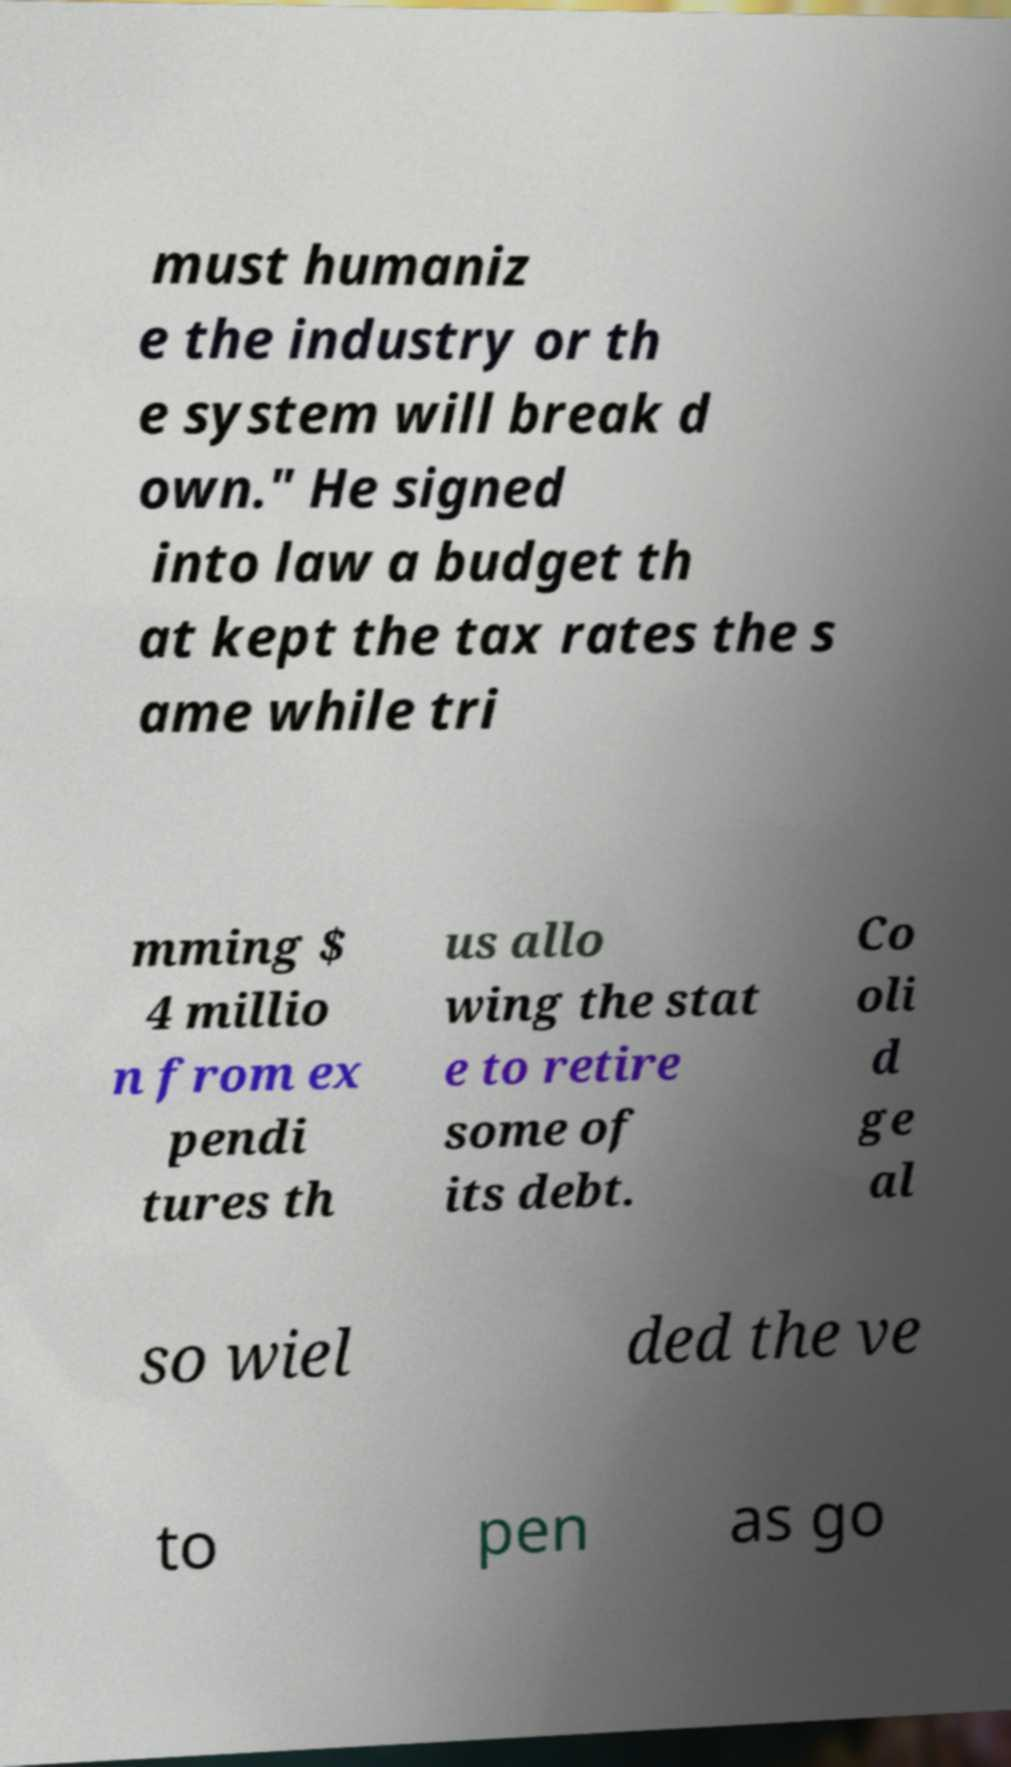I need the written content from this picture converted into text. Can you do that? must humaniz e the industry or th e system will break d own." He signed into law a budget th at kept the tax rates the s ame while tri mming $ 4 millio n from ex pendi tures th us allo wing the stat e to retire some of its debt. Co oli d ge al so wiel ded the ve to pen as go 